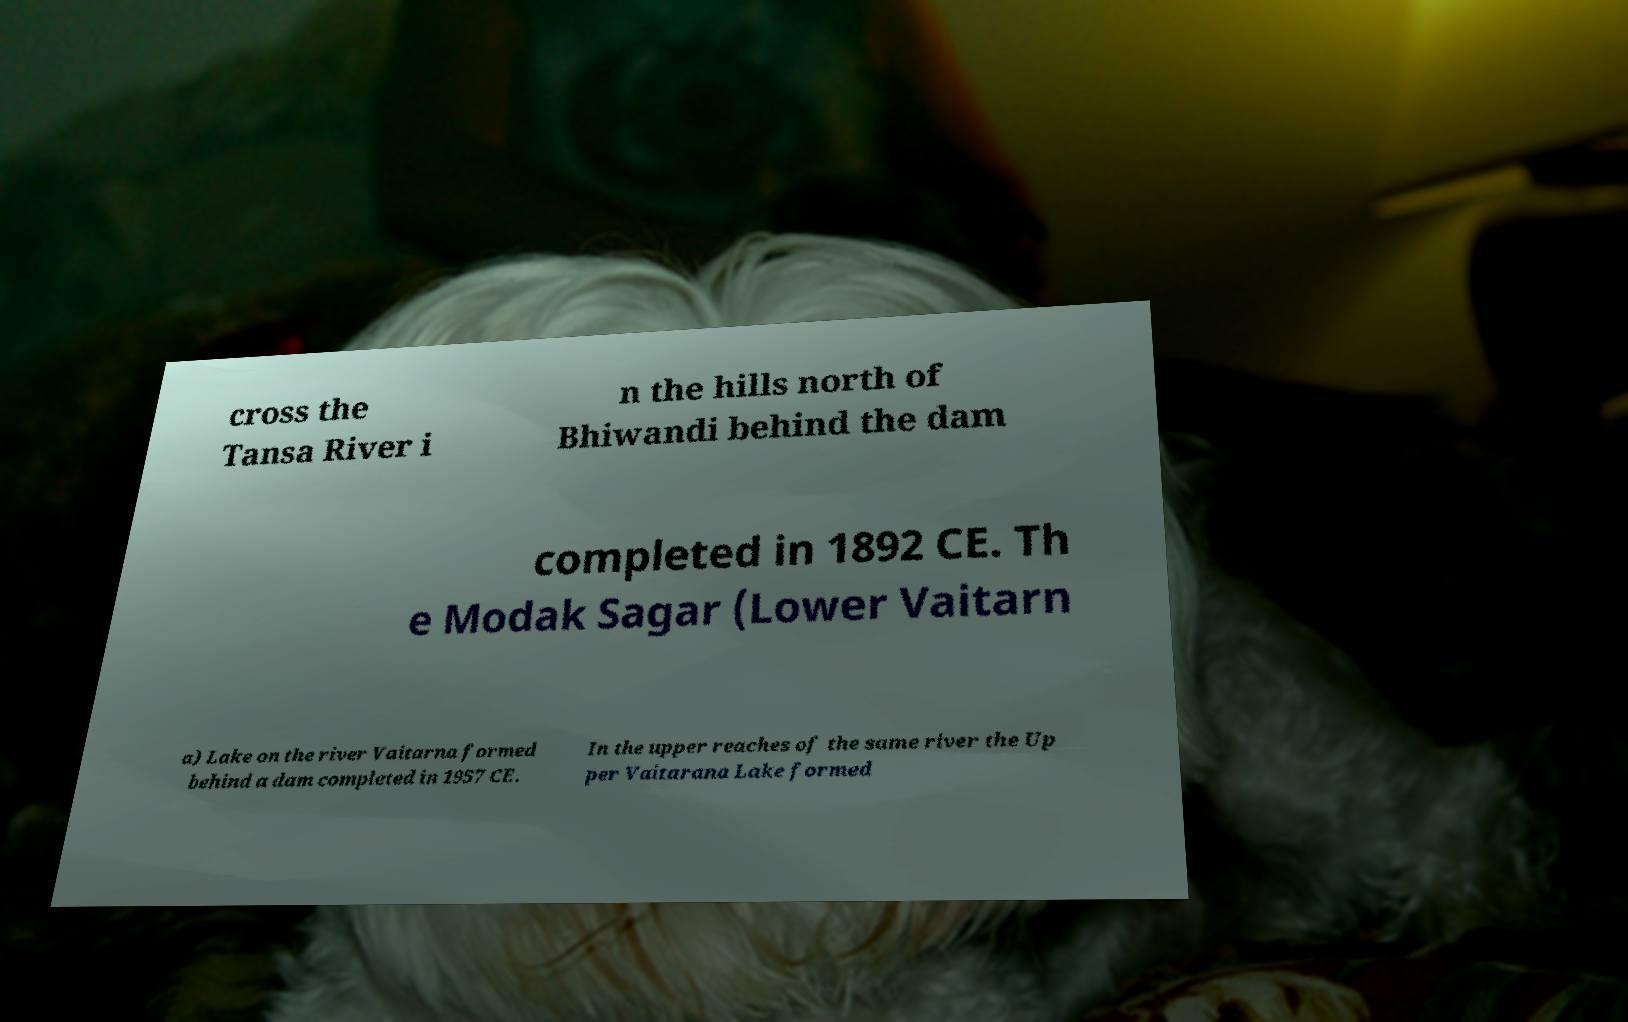Could you assist in decoding the text presented in this image and type it out clearly? cross the Tansa River i n the hills north of Bhiwandi behind the dam completed in 1892 CE. Th e Modak Sagar (Lower Vaitarn a) Lake on the river Vaitarna formed behind a dam completed in 1957 CE. In the upper reaches of the same river the Up per Vaitarana Lake formed 